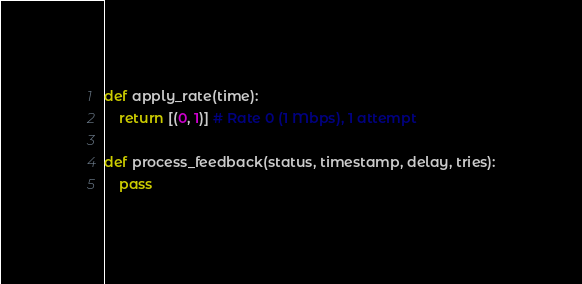Convert code to text. <code><loc_0><loc_0><loc_500><loc_500><_Python_>def apply_rate(time):
    return [(0, 1)] # Rate 0 (1 Mbps), 1 attempt

def process_feedback(status, timestamp, delay, tries):
    pass
</code> 